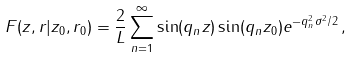Convert formula to latex. <formula><loc_0><loc_0><loc_500><loc_500>F ( z , r | z _ { 0 } , r _ { 0 } ) = \frac { 2 } { L } \sum _ { n = 1 } ^ { \infty } \sin ( q _ { n } z ) \sin ( q _ { n } z _ { 0 } ) e ^ { - q _ { n } ^ { 2 } \sigma ^ { 2 } / 2 } \, ,</formula> 